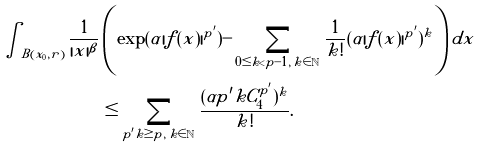<formula> <loc_0><loc_0><loc_500><loc_500>\int _ { B ( x _ { 0 } , r ) } \frac { 1 } { | x | ^ { \beta } } & \left ( \exp ( \alpha | f ( x ) | ^ { p ^ { \prime } } ) - \sum _ { 0 \leq k < p - 1 , \, k \in \mathbb { N } } \frac { 1 } { k ! } ( \alpha | f ( x ) | ^ { p ^ { \prime } } ) ^ { k } \right ) d x \\ & \leq \sum _ { p ^ { \prime } k \geq p , \, k \in \mathbb { N } } \frac { ( \alpha p ^ { \prime } k C _ { 4 } ^ { p ^ { \prime } } ) ^ { k } } { k ! } .</formula> 